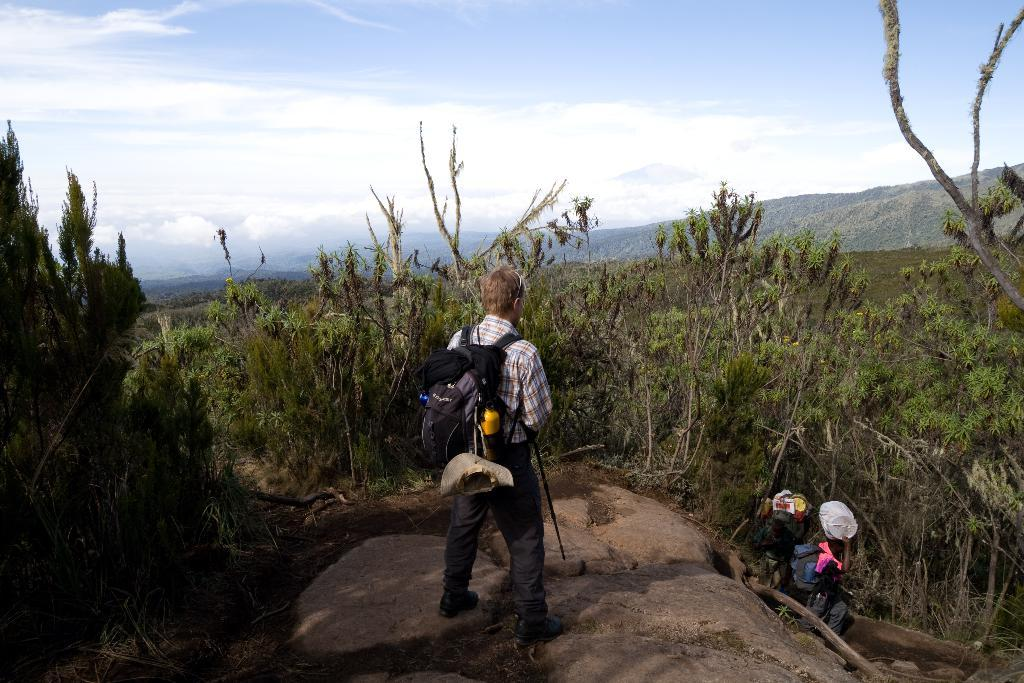How many people are in the image? There are three persons in the image. What are the persons carrying? The persons are carrying bags. What can be seen in the background of the image? There are plants, trees, hills, and the sky visible in the background of the image. What is the condition of the sky in the image? The sky is visible at the top of the image, and there are clouds in the sky. What type of cap is the crook wearing in the image? There is no cap or crook present in the image. 